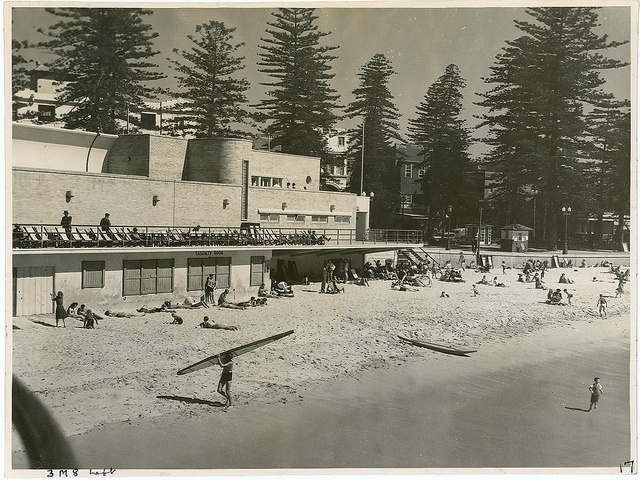Describe the objects in this image and their specific colors. I can see people in white, darkgray, black, lightgray, and gray tones, chair in white, black, gray, darkgray, and darkgreen tones, surfboard in white, gray, black, and darkgreen tones, people in white, black, gray, and darkgray tones, and surfboard in white, darkgray, black, and gray tones in this image. 